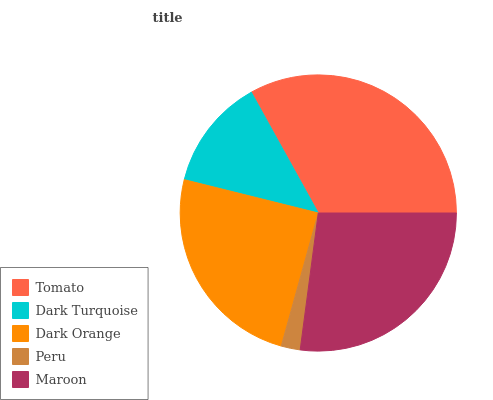Is Peru the minimum?
Answer yes or no. Yes. Is Tomato the maximum?
Answer yes or no. Yes. Is Dark Turquoise the minimum?
Answer yes or no. No. Is Dark Turquoise the maximum?
Answer yes or no. No. Is Tomato greater than Dark Turquoise?
Answer yes or no. Yes. Is Dark Turquoise less than Tomato?
Answer yes or no. Yes. Is Dark Turquoise greater than Tomato?
Answer yes or no. No. Is Tomato less than Dark Turquoise?
Answer yes or no. No. Is Dark Orange the high median?
Answer yes or no. Yes. Is Dark Orange the low median?
Answer yes or no. Yes. Is Dark Turquoise the high median?
Answer yes or no. No. Is Maroon the low median?
Answer yes or no. No. 